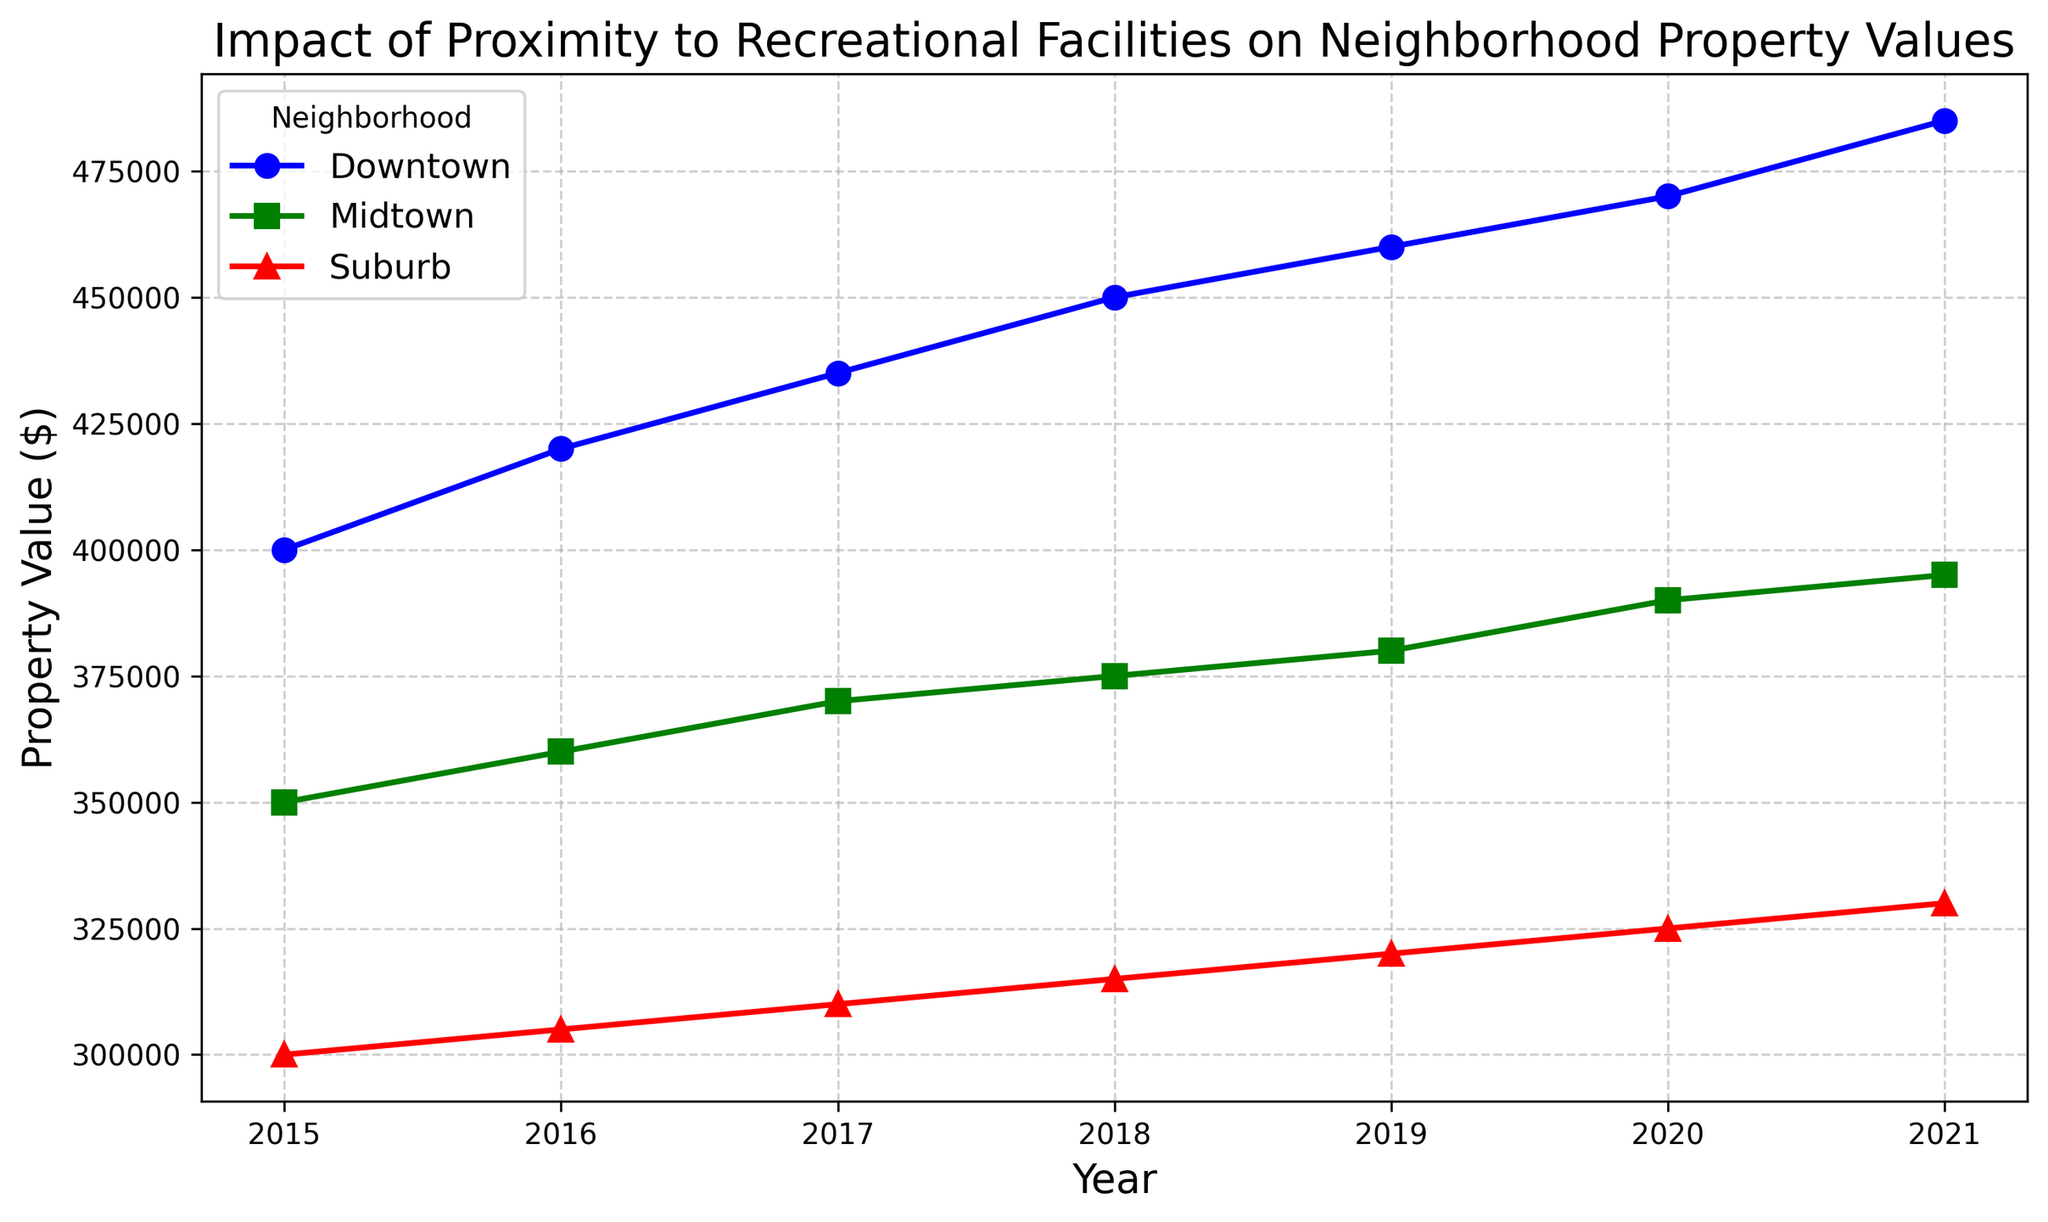How does the property value trend over time differ between Downtown and Suburb? To analyze the trend, we visually examine the lines plotted for Downtown and Suburb. Downtown's property values show a sharper increase compared to Suburb, which has a more gradual rise. Specifically, Downtown starts at $400,000 in 2015 and increases to $485,000 by 2021. In contrast, Suburb starts at $300,000 and increases to $330,000 during the same period.
Answer: Downtown's property values increase more sharply compared to Suburb's What is the difference in property value between Downtown and Midtown in 2021? To find the difference, we identify the property values for both neighborhoods in 2021 from the plot. Downtown has a property value of $485,000, while Midtown has $395,000. Subtract Midtown's value from Downtown's.
Answer: $90,000 Which neighborhood has the highest property value in 2019? We look at the plotted points for each neighborhood in 2019. Downtown is plotted at $460,000, Midtown at $380,000, and Suburb at $320,000.
Answer: Downtown How much did property values in Midtown increase from 2015 to 2020? We need to find Midtown’s property values in both years and subtract the 2015 value from the 2020 value. From the plot, Midtown's value in 2015 is $350,000 and in 2020 it is $390,000. Subtracting these gives the increase.
Answer: $40,000 Which neighborhood shows the least change in property values over the period 2015 to 2021? We compare the slopes of the lines for each neighborhood. Suburb shows the least steep slope, indicating the smallest change.
Answer: Suburb What are the average property values for Downtown and Midtown in 2020? We find the values on the plot for 2020: Downtown is $470,000 and Midtown is $390,000. To get the average, sum these values and divide by 2. (470000 + 390000) / 2.
Answer: $430,000 Between which years did Downtown experience the highest increase in property value? We need to identify the steepest part of the line for Downtown between consecutive years. The steepest increase appears to be between 2015 ($400,000) and 2016 ($420,000), giving a difference of $20,000. Checking other segments confirms this as the highest increase.
Answer: 2015 to 2016 What is the total increase in property value for the Suburb neighborhood from 2015 to 2021? Determine the property values for the Suburb from 2015 ($300,000) to 2021 ($330,000) and calculate the difference.
Answer: $30,000 